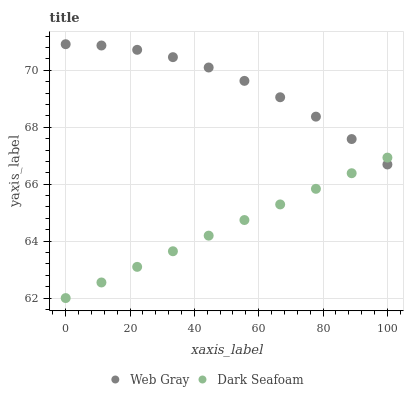Does Dark Seafoam have the minimum area under the curve?
Answer yes or no. Yes. Does Web Gray have the maximum area under the curve?
Answer yes or no. Yes. Does Web Gray have the minimum area under the curve?
Answer yes or no. No. Is Dark Seafoam the smoothest?
Answer yes or no. Yes. Is Web Gray the roughest?
Answer yes or no. Yes. Is Web Gray the smoothest?
Answer yes or no. No. Does Dark Seafoam have the lowest value?
Answer yes or no. Yes. Does Web Gray have the lowest value?
Answer yes or no. No. Does Web Gray have the highest value?
Answer yes or no. Yes. Does Dark Seafoam intersect Web Gray?
Answer yes or no. Yes. Is Dark Seafoam less than Web Gray?
Answer yes or no. No. Is Dark Seafoam greater than Web Gray?
Answer yes or no. No. 